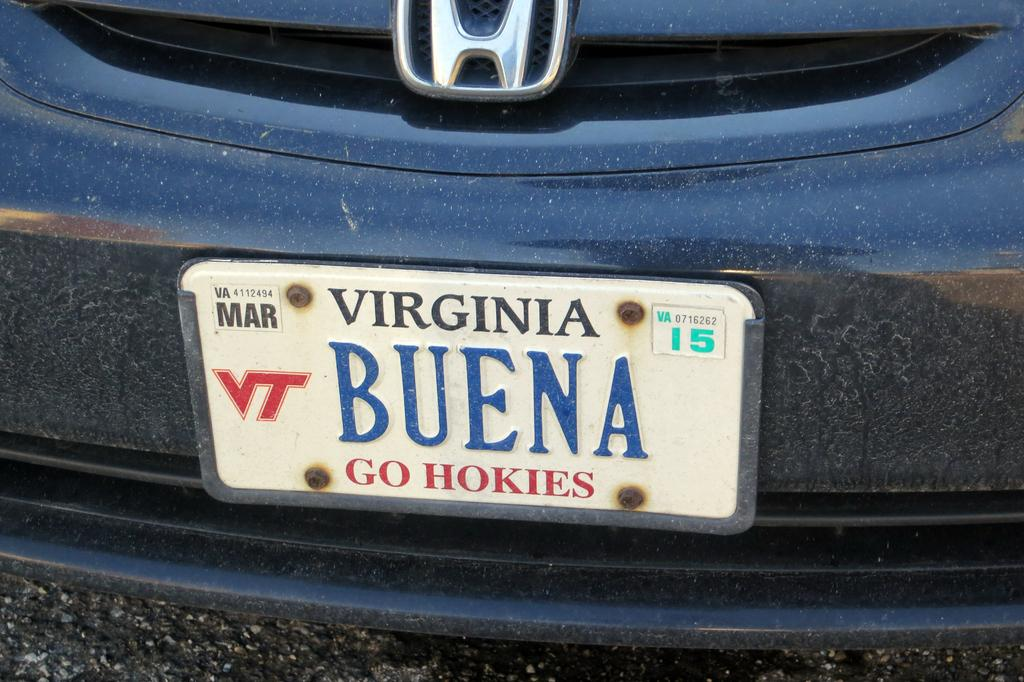<image>
Give a short and clear explanation of the subsequent image. A Buena sign on the back of a car 